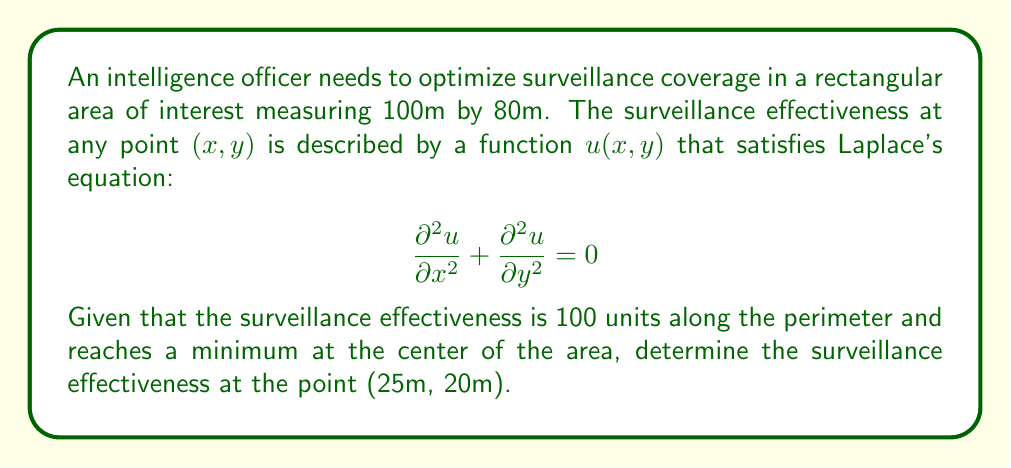Provide a solution to this math problem. To solve this problem, we need to use the properties of Laplace's equation and the given boundary conditions:

1. The area is rectangular, so we can use separation of variables to solve Laplace's equation.

2. The general solution for a rectangular domain with these boundary conditions is:

   $$u(x,y) = 100 - \sum_{n=1}^{\infty} \frac{400}{n\pi} \sinh\left(\frac{n\pi y}{100}\right) \sin\left(\frac{n\pi x}{100}\right) \frac{\sinh\left(\frac{n\pi(80-y)}{100}\right)}{\sinh\left(\frac{80n\pi}{100}\right)}$$

3. To find the value at (25m, 20m), we need to substitute x=25 and y=20 into this equation.

4. In practice, we can approximate the solution by taking the first few terms of the series. Let's use the first three terms (n=1, 2, 3):

   $$u(25,20) \approx 100 - \frac{400}{\pi} \left[\frac{1}{1} \cdot f(1) + \frac{1}{2} \cdot f(2) + \frac{1}{3} \cdot f(3)\right]$$

   where $f(n) = \sinh\left(\frac{n\pi \cdot 20}{100}\right) \sin\left(\frac{n\pi \cdot 25}{100}\right) \frac{\sinh\left(\frac{n\pi(80-20)}{100}\right)}{\sinh\left(\frac{80n\pi}{100}\right)}$

5. Calculating these terms:
   
   $f(1) \approx 0.3090 \cdot 0.7071 \cdot 0.9542 = 0.2087$
   $f(2) \approx 0.5877 \cdot 1.0000 \cdot 0.9998 = 0.5876$
   $f(3) \approx 0.8090 \cdot 0.7071 \cdot 1.0000 = 0.5721$

6. Substituting into the equation:

   $$u(25,20) \approx 100 - \frac{400}{\pi} \left[0.2087 + \frac{0.5876}{2} + \frac{0.5721}{3}\right] \approx 100 - 42.89 = 57.11$$

Therefore, the surveillance effectiveness at (25m, 20m) is approximately 57.11 units.
Answer: 57.11 units 